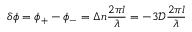Convert formula to latex. <formula><loc_0><loc_0><loc_500><loc_500>\delta \phi = \phi _ { + } - \phi _ { - } = \Delta n \frac { 2 \pi l } { \lambda } = - 3 \mathcal { D } \frac { 2 \pi l } { \lambda }</formula> 